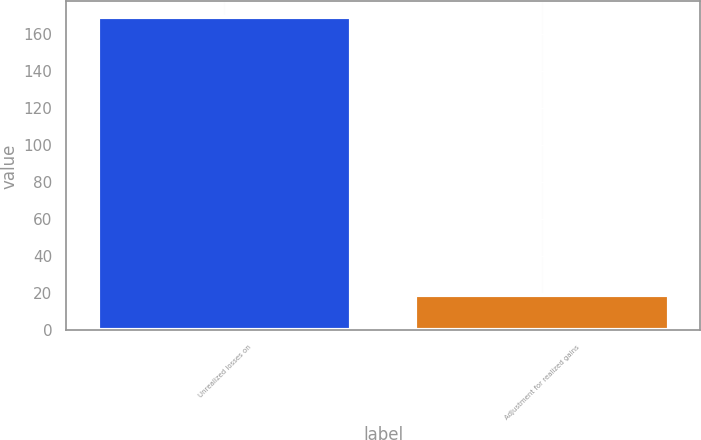Convert chart to OTSL. <chart><loc_0><loc_0><loc_500><loc_500><bar_chart><fcel>Unrealized losses on<fcel>Adjustment for realized gains<nl><fcel>168.9<fcel>19<nl></chart> 